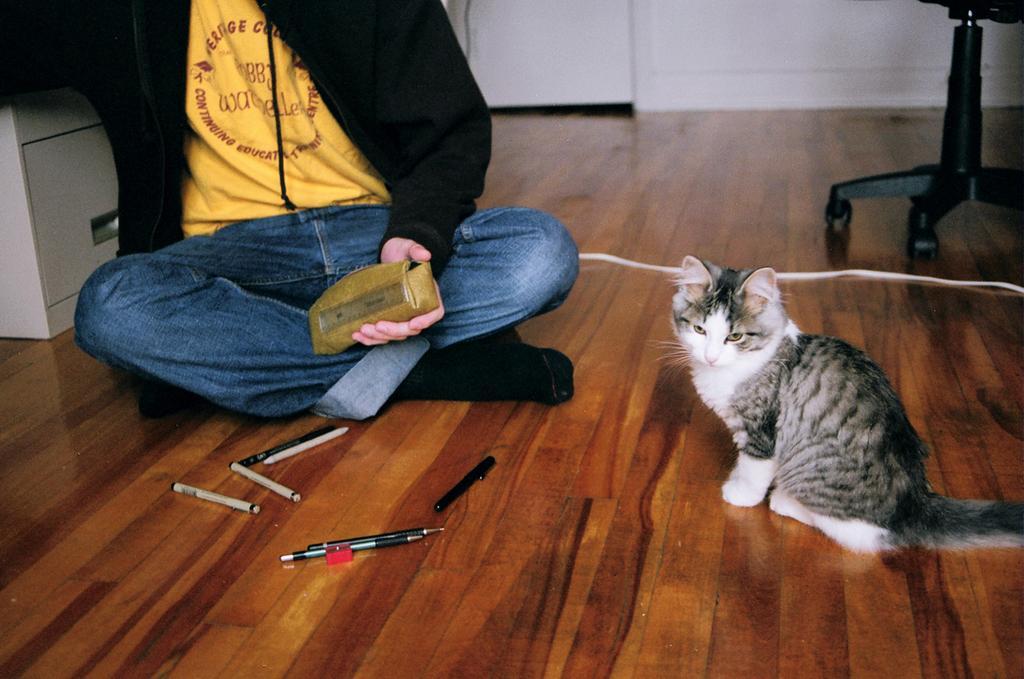In one or two sentences, can you explain what this image depicts? In this picture we can see a person and a cat is seated on the floor, in front of the person we can see few pens and a sharpener, beside to the cat we can find a cable and a chair. 